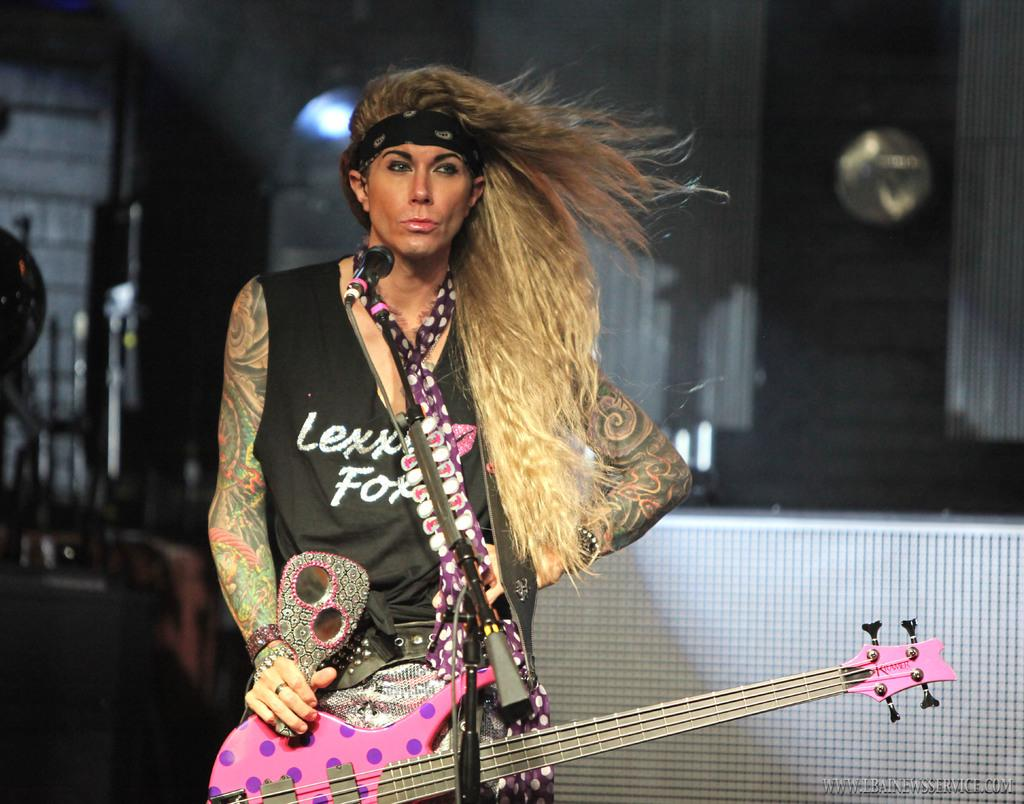Who is the main subject in the image? There is a woman in the image. What is the woman wearing? The woman is wearing a guitar. What equipment is set up in front of the woman? There is a microphone with a stand in front of the woman. What can be seen in the background of the image? There is a light and a wall visible in the image. What type of suit is the beast wearing in the image? There is no beast or suit present in the image; it features a woman wearing a guitar. Can you tell me where the vase is located in the image? There is no vase present in the image. 